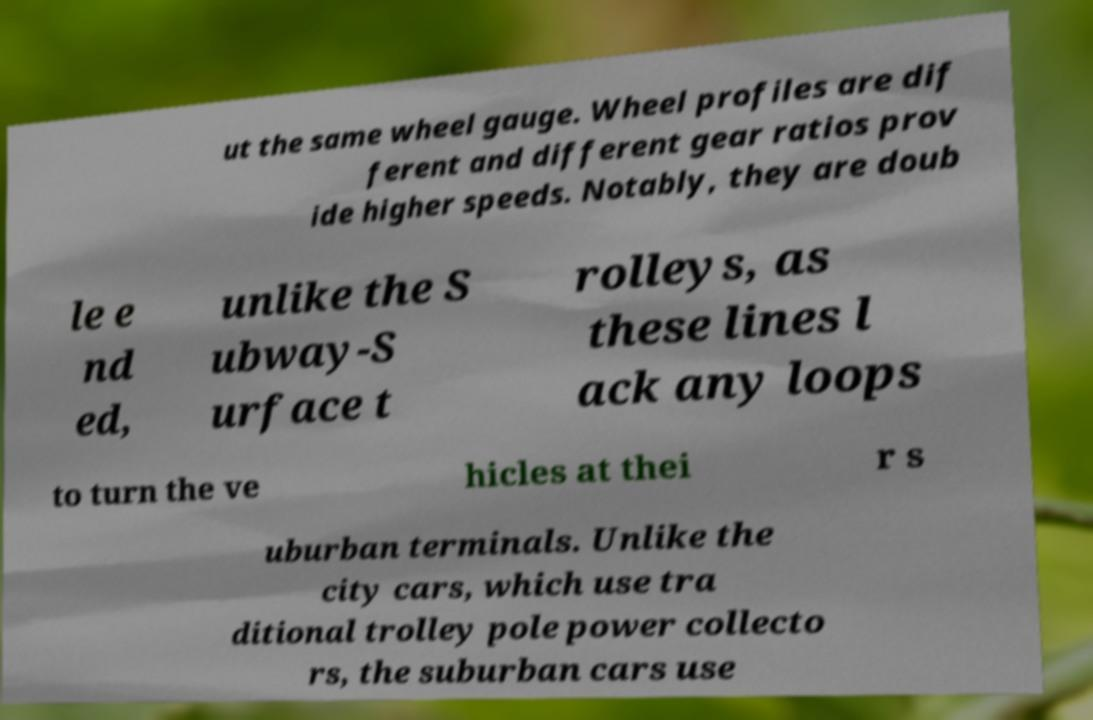For documentation purposes, I need the text within this image transcribed. Could you provide that? ut the same wheel gauge. Wheel profiles are dif ferent and different gear ratios prov ide higher speeds. Notably, they are doub le e nd ed, unlike the S ubway-S urface t rolleys, as these lines l ack any loops to turn the ve hicles at thei r s uburban terminals. Unlike the city cars, which use tra ditional trolley pole power collecto rs, the suburban cars use 